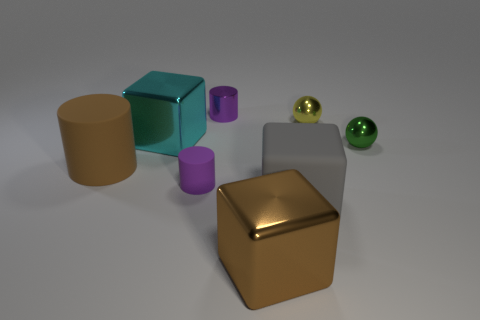Subtract all metal cubes. How many cubes are left? 1 Subtract 2 cubes. How many cubes are left? 1 Subtract all spheres. How many objects are left? 6 Add 1 yellow metal objects. How many objects exist? 9 Subtract all yellow cylinders. Subtract all green cubes. How many cylinders are left? 3 Subtract all green spheres. How many green cylinders are left? 0 Subtract all yellow metallic balls. Subtract all red cylinders. How many objects are left? 7 Add 1 tiny matte cylinders. How many tiny matte cylinders are left? 2 Add 5 tiny yellow spheres. How many tiny yellow spheres exist? 6 Subtract all yellow balls. How many balls are left? 1 